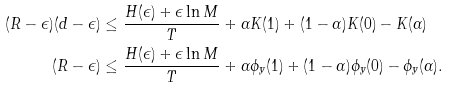Convert formula to latex. <formula><loc_0><loc_0><loc_500><loc_500>( R - \epsilon ) ( d - \epsilon ) & \leq \frac { H ( \epsilon ) + \epsilon \ln M } { T } + \alpha K ( 1 ) + ( 1 - \alpha ) K ( 0 ) - K ( \alpha ) \\ ( R - \epsilon ) & \leq \frac { H ( \epsilon ) + \epsilon \ln M } { T } + \alpha \phi _ { y } ( 1 ) + ( 1 - \alpha ) \phi _ { y } ( 0 ) - \phi _ { y } ( \alpha ) .</formula> 